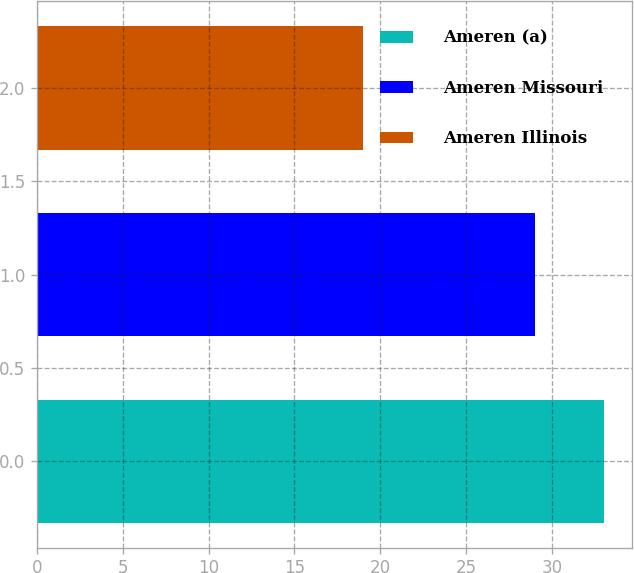Convert chart. <chart><loc_0><loc_0><loc_500><loc_500><bar_chart><fcel>Ameren (a)<fcel>Ameren Missouri<fcel>Ameren Illinois<nl><fcel>33<fcel>29<fcel>19<nl></chart> 